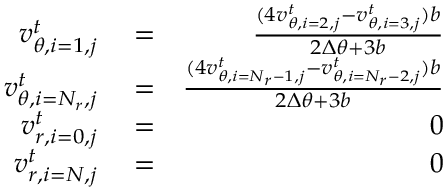<formula> <loc_0><loc_0><loc_500><loc_500>\begin{array} { r l r } { v _ { \theta , i = 1 , j } ^ { t } } & = } & { \frac { ( 4 v _ { \theta , i = 2 , j } ^ { t } - v _ { \theta , i = 3 , j } ^ { t } ) b } { 2 \Delta \theta + 3 b } } \\ { v _ { \theta , i = N _ { r } , j } ^ { t } } & = } & { \frac { ( 4 v _ { \theta , i = N _ { r } - 1 , j } ^ { t } - v _ { \theta , i = N _ { r } - 2 , j } ^ { t } ) b } { 2 \Delta \theta + 3 b } } \\ { v _ { r , i = 0 , j } ^ { t } } & = } & { 0 } \\ { v _ { r , i = N , j } ^ { t } } & = } & { 0 } \end{array}</formula> 